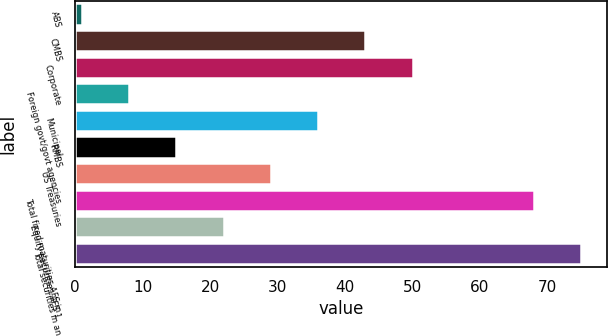Convert chart. <chart><loc_0><loc_0><loc_500><loc_500><bar_chart><fcel>ABS<fcel>CMBS<fcel>Corporate<fcel>Foreign govt/govt agencies<fcel>Municipal<fcel>RMBS<fcel>US Treasuries<fcel>Total fixed maturities AFS in<fcel>Equity securities AFS 1<fcel>Total securities in an<nl><fcel>1<fcel>43<fcel>50<fcel>8<fcel>36<fcel>15<fcel>29<fcel>68<fcel>22<fcel>75<nl></chart> 